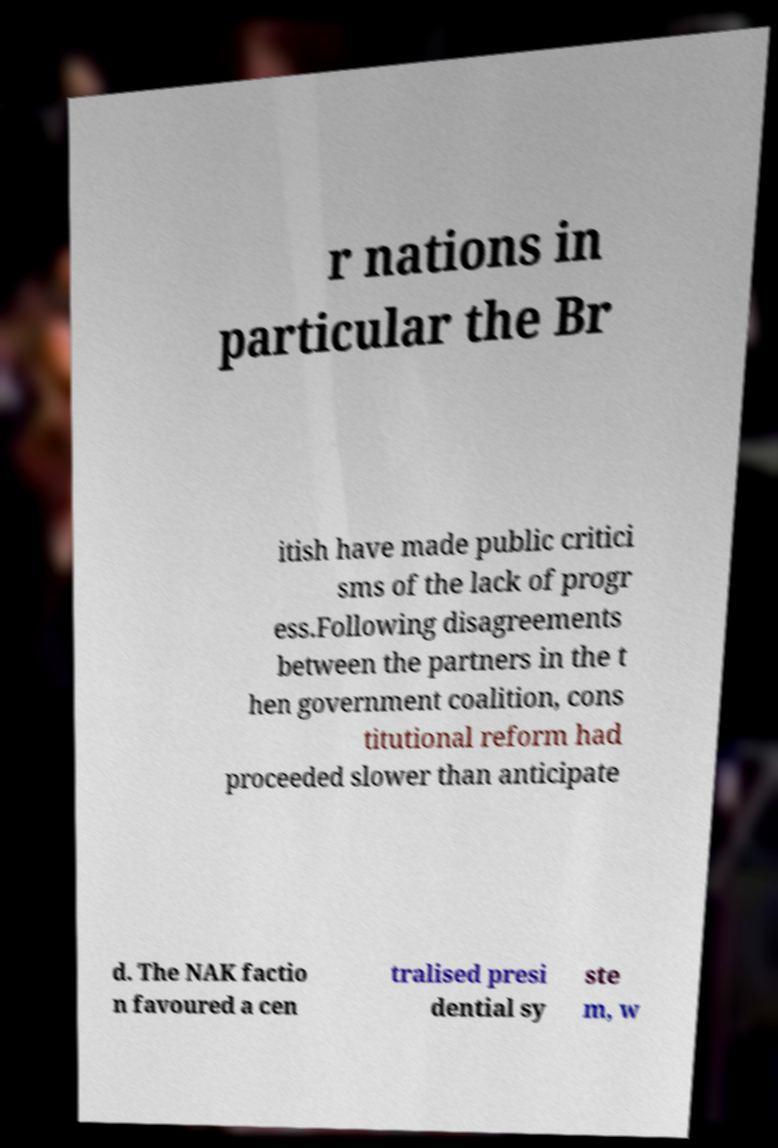Please read and relay the text visible in this image. What does it say? r nations in particular the Br itish have made public critici sms of the lack of progr ess.Following disagreements between the partners in the t hen government coalition, cons titutional reform had proceeded slower than anticipate d. The NAK factio n favoured a cen tralised presi dential sy ste m, w 